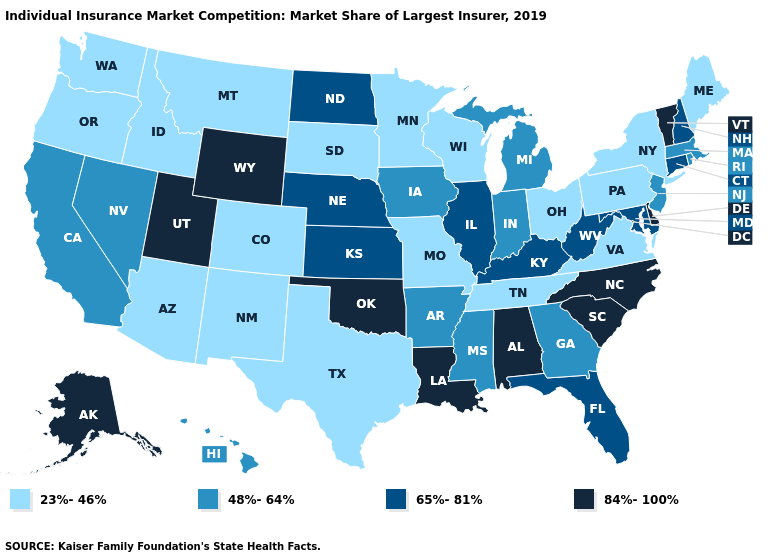What is the highest value in the USA?
Answer briefly. 84%-100%. What is the value of Florida?
Concise answer only. 65%-81%. What is the value of Iowa?
Be succinct. 48%-64%. Among the states that border Oregon , which have the lowest value?
Quick response, please. Idaho, Washington. What is the lowest value in the USA?
Short answer required. 23%-46%. Which states have the lowest value in the USA?
Keep it brief. Arizona, Colorado, Idaho, Maine, Minnesota, Missouri, Montana, New Mexico, New York, Ohio, Oregon, Pennsylvania, South Dakota, Tennessee, Texas, Virginia, Washington, Wisconsin. Among the states that border Oregon , does Nevada have the lowest value?
Keep it brief. No. Does the map have missing data?
Write a very short answer. No. Which states have the lowest value in the USA?
Answer briefly. Arizona, Colorado, Idaho, Maine, Minnesota, Missouri, Montana, New Mexico, New York, Ohio, Oregon, Pennsylvania, South Dakota, Tennessee, Texas, Virginia, Washington, Wisconsin. Does Idaho have the highest value in the USA?
Be succinct. No. Name the states that have a value in the range 84%-100%?
Keep it brief. Alabama, Alaska, Delaware, Louisiana, North Carolina, Oklahoma, South Carolina, Utah, Vermont, Wyoming. What is the lowest value in the Northeast?
Be succinct. 23%-46%. Name the states that have a value in the range 23%-46%?
Short answer required. Arizona, Colorado, Idaho, Maine, Minnesota, Missouri, Montana, New Mexico, New York, Ohio, Oregon, Pennsylvania, South Dakota, Tennessee, Texas, Virginia, Washington, Wisconsin. What is the highest value in states that border Maryland?
Give a very brief answer. 84%-100%. What is the value of South Carolina?
Answer briefly. 84%-100%. 